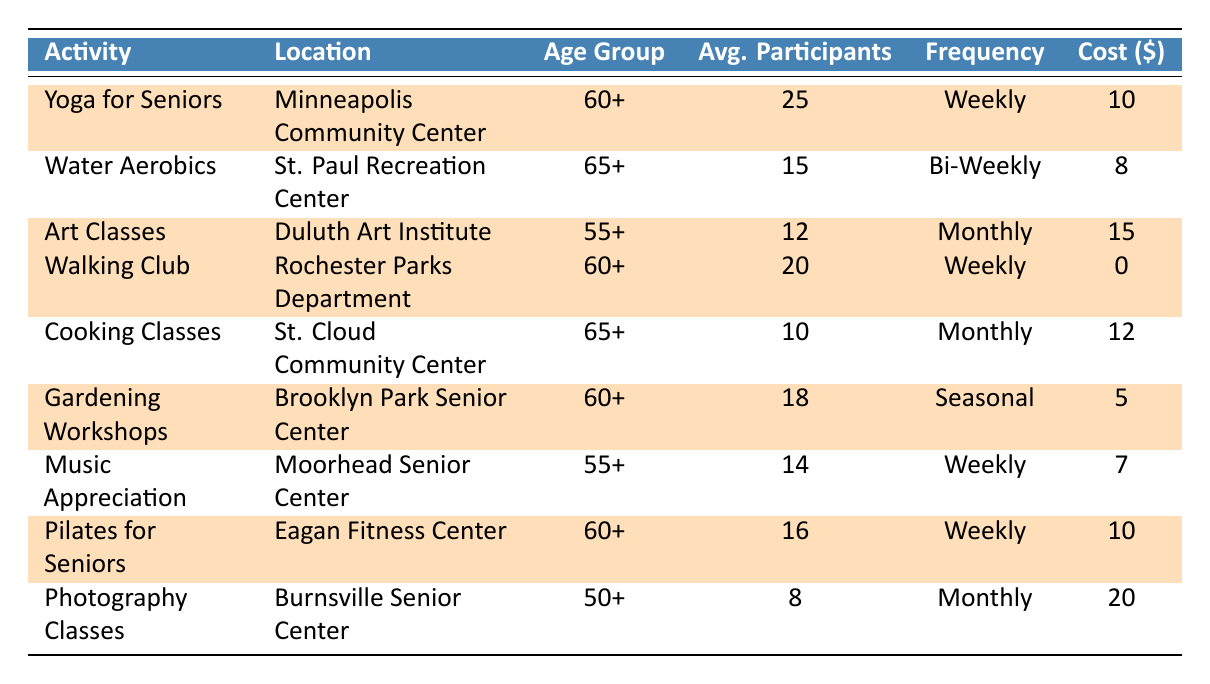What is the average cost of the highlighted activities? To find the average cost of the highlighted activities, sum the costs of Yoga for Seniors (10), Art Classes (15), Walking Club (0), Gardening Workshops (5), and Pilates for Seniors (10). The total cost is 10 + 15 + 0 + 5 + 10 = 40. There are 5 highlighted activities, so the average cost is 40/5 = 8.
Answer: 8 How many total participants are there across all activities? The total participants are found by summing the average participants from all activities listed. The totals are: Yoga for Seniors (25), Water Aerobics (15), Art Classes (12), Walking Club (20), Cooking Classes (10), Gardening Workshops (18), Music Appreciation (14), Pilates for Seniors (16), and Photography Classes (8). Adding these gives 25 + 15 + 12 + 20 + 10 + 18 + 14 + 16 + 8 = 128.
Answer: 128 Does the Walking Club have the highest average number of participants among the highlighted activities? The highlighted activities and their average participants are: Yoga for Seniors (25), Art Classes (12), Walking Club (20), Gardening Workshops (18), and Pilates for Seniors (16). The highest number among these is 25 from Yoga for Seniors, meaning Walking Club does not have the highest.
Answer: No Which activity has the lowest cost per class? Comparing the costs of all activities: Yoga for Seniors (10), Water Aerobics (8), Art Classes (15), Walking Club (0), Cooking Classes (12), Gardening Workshops (5), Music Appreciation (7), Pilates for Seniors (10), and Photography Classes (20). Walking Club has a cost of 0, which is the lowest.
Answer: Walking Club How many activities are available that target seniors aged 60 or older? The activities for the age group of 60+ are: Yoga for Seniors, Walking Club, Gardening Workshops, and Pilates for Seniors. Counting these gives a total of 4 activities.
Answer: 4 What is the total cost of attending all seasonal activities listed? The only seasonal activity is Gardening Workshops, which costs 5 per class. Since there is only one, the total cost is simply 5.
Answer: 5 Which activity has the most participants and is also highlighted? The highlighted activities and their average participants are: Yoga for Seniors (25), Art Classes (12), Walking Club (20), Gardening Workshops (18), and Pilates for Seniors (16). The most participants in the highlighted activities is 25 from Yoga for Seniors.
Answer: Yoga for Seniors Is there any highlighted activity that occurs monthly? The highlighted activities occurring monthly are Art Classes (Monthly). The others are either weekly, bi-weekly, or seasonal. Thus, there is one highlighted activity that occurs monthly.
Answer: Yes, Art Classes 